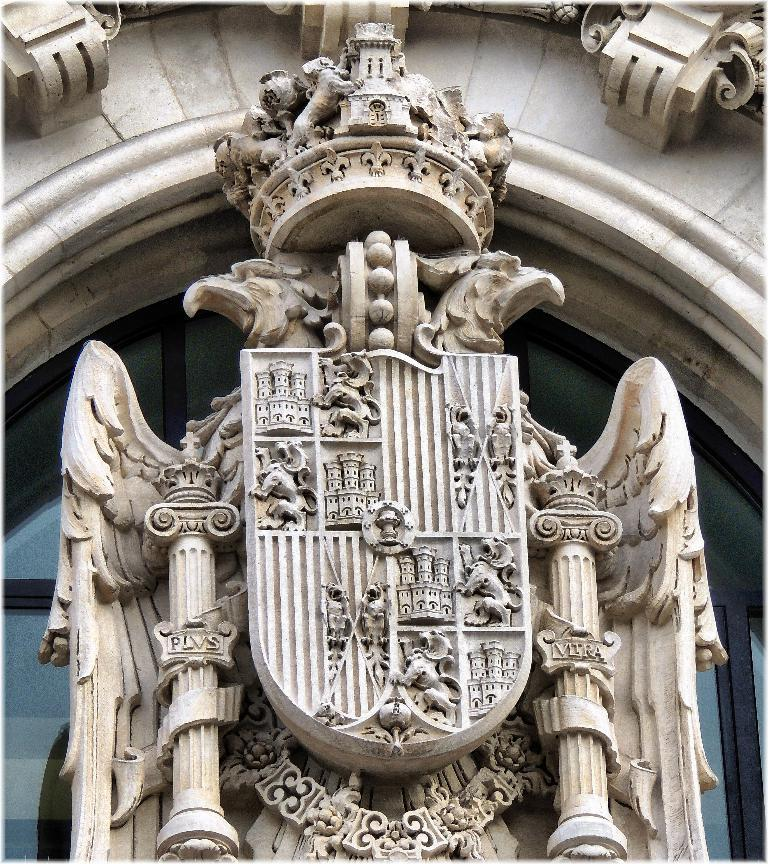What type of sculptures can be seen in the image? There are sculptures in the shape of animals in the image. Are there any other types of sculptures besides the animal-shaped ones? Yes, there are other sculptures in the image. What is visible in the background of the image? There is a framed glass wall in the background of the image. What grade does the library receive for its roll in the image? There is no library or roll present in the image, so it is not possible to determine a grade. 